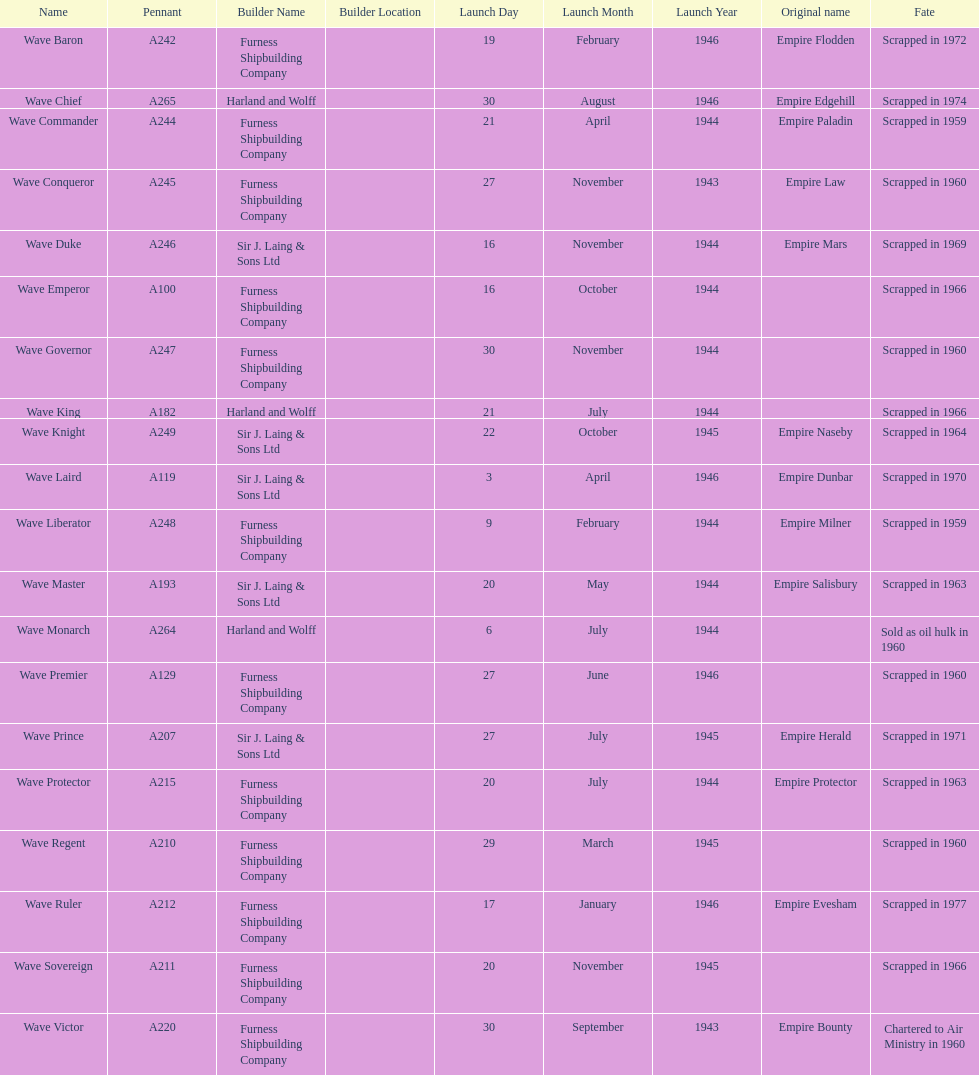Name a builder with "and" in the name. Harland and Wolff. 